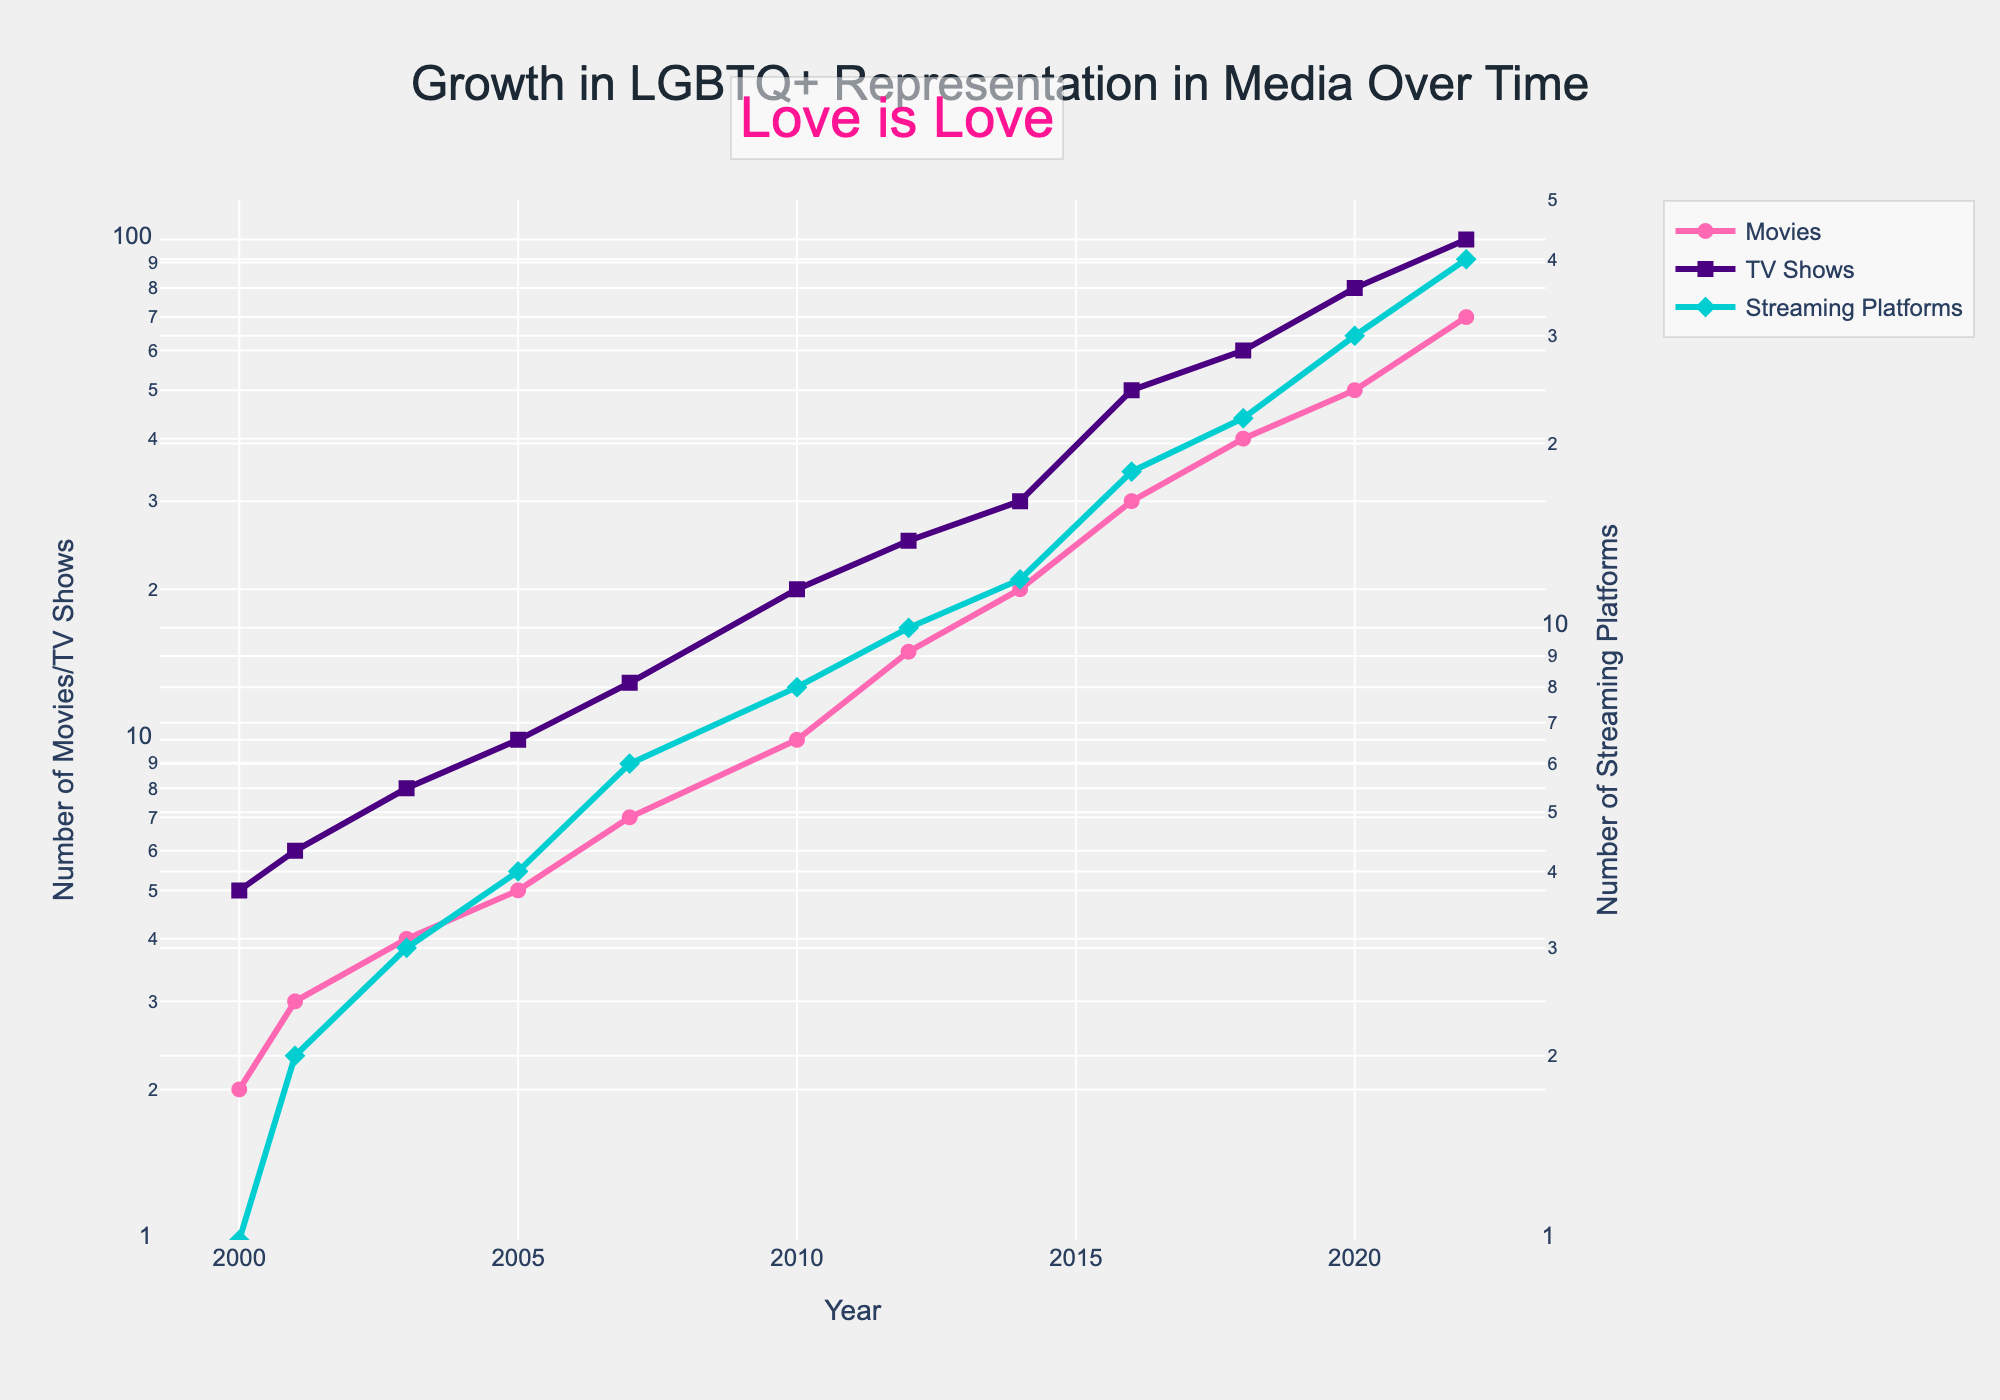What is the title of the figure? The title is usually the biggest and most prominent text at the top of the figure, summarizing what the figure is about.
Answer: Growth in LGBTQ+ Representation in Media Over Time How many different media types are represented in the figure? The legend provides information about different media types with distinct colors and markers.
Answer: Three What color represents the "Movies" in the plot? By looking at the legend and matching the color to the plot lines, the color can be identified.
Answer: Pink At what year did TV shows reach 60 in number? Find the TV Shows line (purple), and locate the year corresponding to the value of 60.
Answer: 2018 Which year shows the fastest growth in LGBTQ+ representation in movies between two consecutive points? Examine the intervals between the years on the Movies line to identify the sharpest increase in height.
Answer: 2018 to 2020 What is the approximate difference in the number of streaming platforms between 2000 and 2022? Subtract the value for 2000 from the value for 2022 based on the Streaming Platforms line (cyan).
Answer: 39 How does the growth trend of LGBTQ+ representation in TV shows compare to streaming platforms from 2014 to 2016? Look at the slopes of the lines for TV Shows (purple) and Streaming Platforms (cyan) between 2014 and 2016.
Answer: Both increased, with TV Shows showing a steeper increase What is the y-axis scale type used for the number of movies/tv shows in the figure? The scale type can be determined by observing the axis labels and spacing.
Answer: Logarithmic Between which years do all three media types show a significant upward trend? Identify periods where all lines are noticeably increasing in the upward direction.
Answer: 2014 to 2016 What message is conveyed by the annotation in the plot? The annotation is a text box usually intended to emphasize a particular message or detail within the plot; located above or in a contrasting color.
Answer: Love is Love 